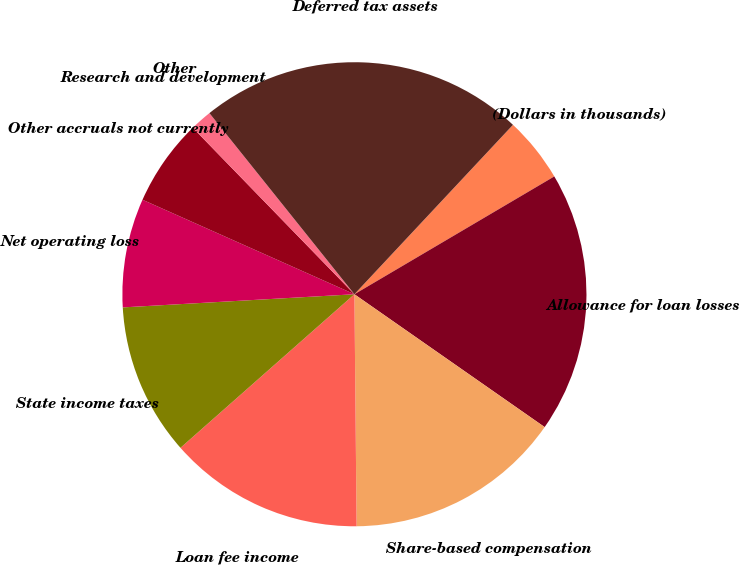<chart> <loc_0><loc_0><loc_500><loc_500><pie_chart><fcel>(Dollars in thousands)<fcel>Allowance for loan losses<fcel>Share-based compensation<fcel>Loan fee income<fcel>State income taxes<fcel>Net operating loss<fcel>Other accruals not currently<fcel>Research and development<fcel>Other<fcel>Deferred tax assets<nl><fcel>4.55%<fcel>18.18%<fcel>15.15%<fcel>13.64%<fcel>10.61%<fcel>7.58%<fcel>6.06%<fcel>1.52%<fcel>0.0%<fcel>22.72%<nl></chart> 